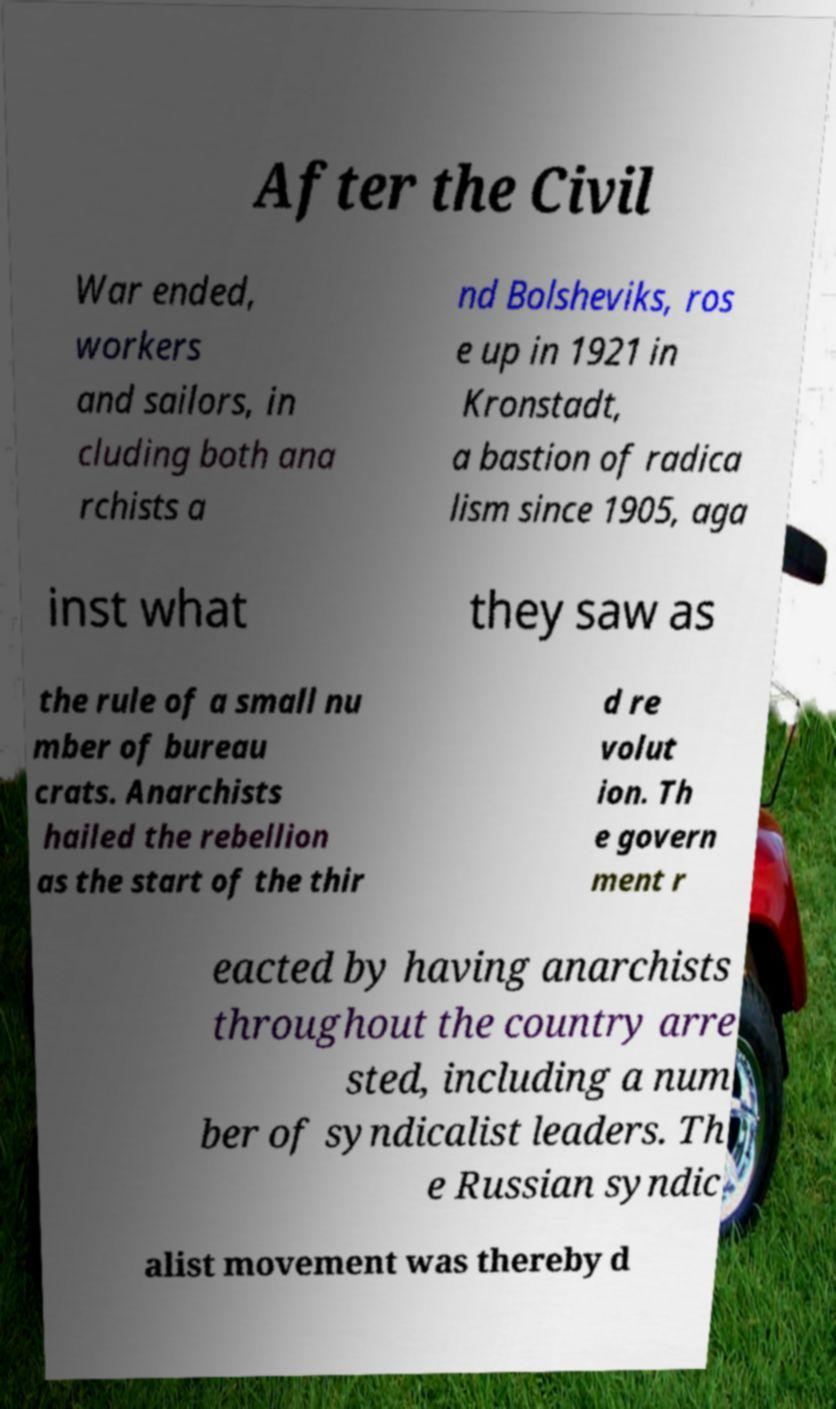What messages or text are displayed in this image? I need them in a readable, typed format. After the Civil War ended, workers and sailors, in cluding both ana rchists a nd Bolsheviks, ros e up in 1921 in Kronstadt, a bastion of radica lism since 1905, aga inst what they saw as the rule of a small nu mber of bureau crats. Anarchists hailed the rebellion as the start of the thir d re volut ion. Th e govern ment r eacted by having anarchists throughout the country arre sted, including a num ber of syndicalist leaders. Th e Russian syndic alist movement was thereby d 